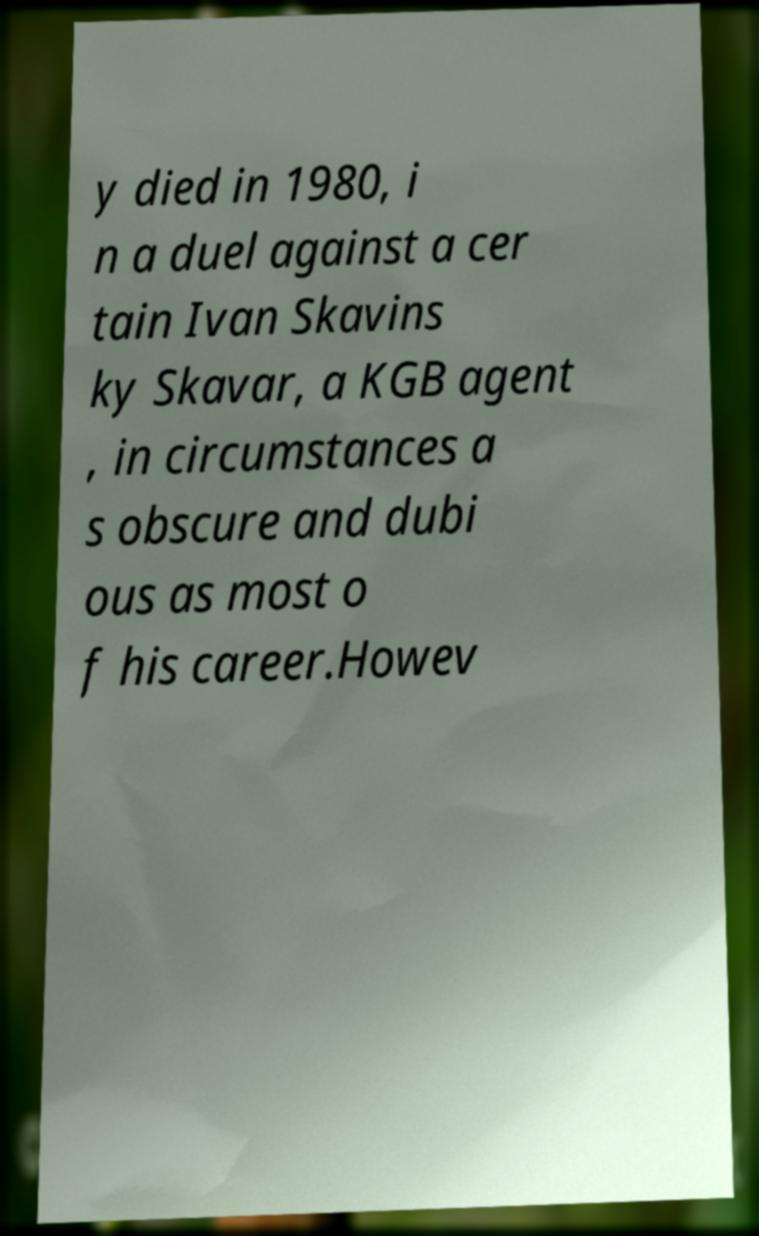Could you assist in decoding the text presented in this image and type it out clearly? y died in 1980, i n a duel against a cer tain Ivan Skavins ky Skavar, a KGB agent , in circumstances a s obscure and dubi ous as most o f his career.Howev 